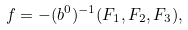<formula> <loc_0><loc_0><loc_500><loc_500>f = - ( b ^ { 0 } ) ^ { - 1 } ( F _ { 1 } , F _ { 2 } , F _ { 3 } ) ,</formula> 